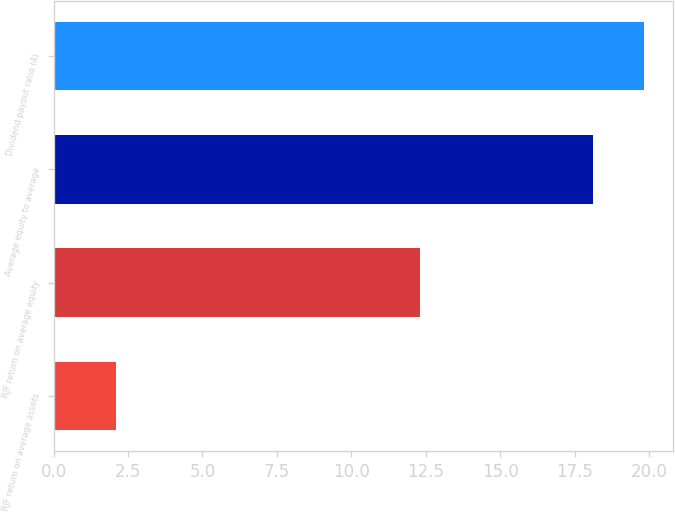Convert chart to OTSL. <chart><loc_0><loc_0><loc_500><loc_500><bar_chart><fcel>RJF return on average assets<fcel>RJF return on average equity<fcel>Average equity to average<fcel>Dividend payout ratio (4)<nl><fcel>2.1<fcel>12.3<fcel>18.1<fcel>19.82<nl></chart> 